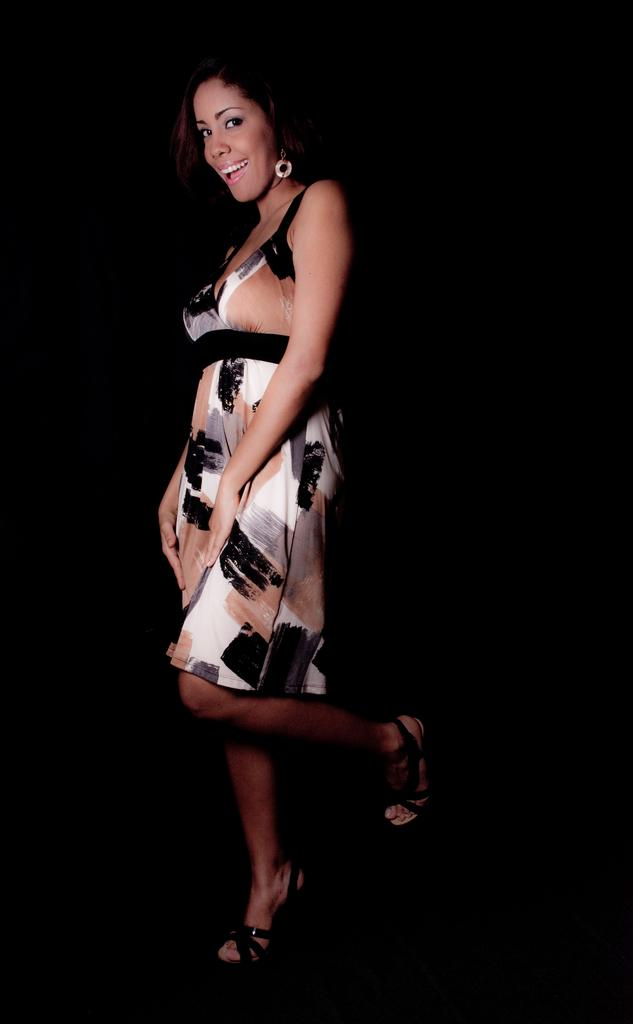Who is the main subject in the image? There is a lady in the center of the image. What color is the background of the image? The background of the image is black in color. Can you see a robin in the image? No, there is no robin present in the image. What is the value of the lady's smile in the image? The image does not depict a smile, so it is not possible to determine the value of a smile. 